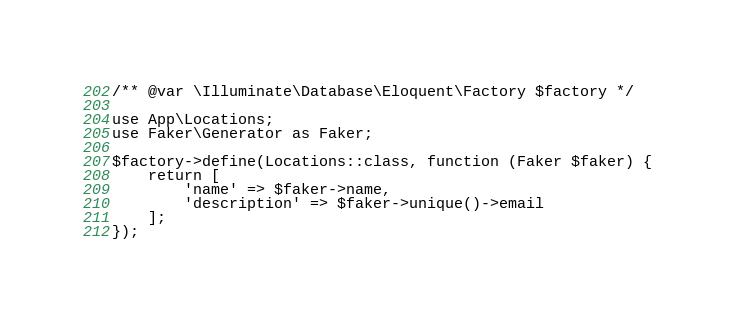<code> <loc_0><loc_0><loc_500><loc_500><_PHP_>/** @var \Illuminate\Database\Eloquent\Factory $factory */

use App\Locations;
use Faker\Generator as Faker;

$factory->define(Locations::class, function (Faker $faker) {
    return [
        'name' => $faker->name,
        'description' => $faker->unique()->email
    ];
});
</code> 